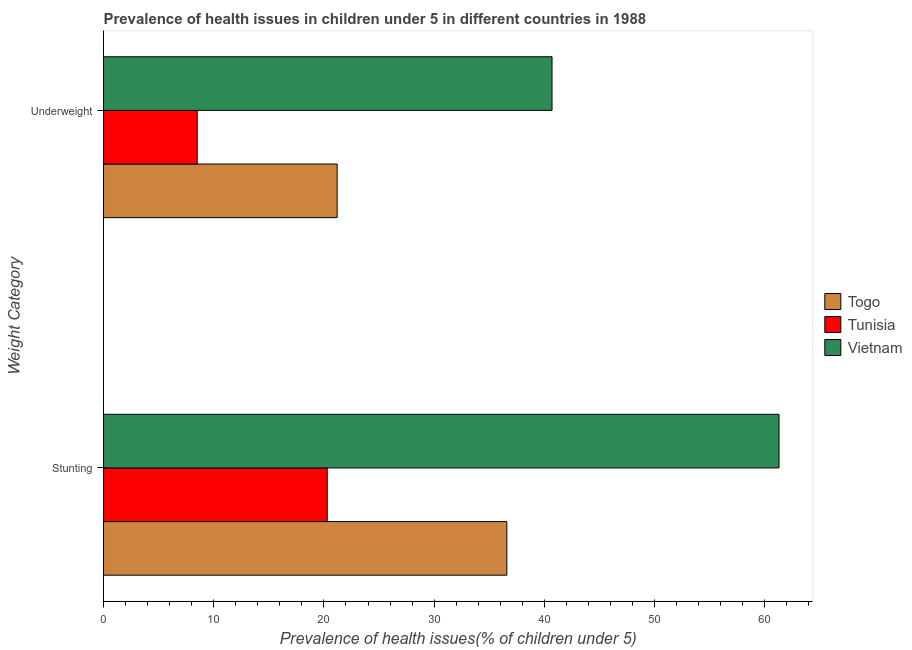Are the number of bars on each tick of the Y-axis equal?
Keep it short and to the point. Yes. How many bars are there on the 2nd tick from the top?
Your answer should be compact. 3. How many bars are there on the 2nd tick from the bottom?
Keep it short and to the point. 3. What is the label of the 2nd group of bars from the top?
Your answer should be compact. Stunting. What is the percentage of stunted children in Vietnam?
Your answer should be compact. 61.3. Across all countries, what is the maximum percentage of stunted children?
Offer a very short reply. 61.3. In which country was the percentage of stunted children maximum?
Your response must be concise. Vietnam. In which country was the percentage of underweight children minimum?
Give a very brief answer. Tunisia. What is the total percentage of stunted children in the graph?
Give a very brief answer. 118.2. What is the difference between the percentage of underweight children in Tunisia and that in Togo?
Provide a short and direct response. -12.7. What is the difference between the percentage of stunted children in Vietnam and the percentage of underweight children in Togo?
Keep it short and to the point. 40.1. What is the average percentage of stunted children per country?
Your answer should be very brief. 39.4. What is the difference between the percentage of stunted children and percentage of underweight children in Tunisia?
Offer a terse response. 11.8. In how many countries, is the percentage of underweight children greater than 50 %?
Offer a very short reply. 0. What is the ratio of the percentage of underweight children in Vietnam to that in Tunisia?
Ensure brevity in your answer.  4.79. Is the percentage of underweight children in Togo less than that in Tunisia?
Offer a very short reply. No. In how many countries, is the percentage of stunted children greater than the average percentage of stunted children taken over all countries?
Offer a very short reply. 1. What does the 2nd bar from the top in Stunting represents?
Your answer should be very brief. Tunisia. What does the 2nd bar from the bottom in Stunting represents?
Offer a terse response. Tunisia. What is the difference between two consecutive major ticks on the X-axis?
Keep it short and to the point. 10. Does the graph contain any zero values?
Your answer should be very brief. No. Does the graph contain grids?
Provide a short and direct response. No. Where does the legend appear in the graph?
Your response must be concise. Center right. How many legend labels are there?
Make the answer very short. 3. How are the legend labels stacked?
Your answer should be compact. Vertical. What is the title of the graph?
Keep it short and to the point. Prevalence of health issues in children under 5 in different countries in 1988. Does "Botswana" appear as one of the legend labels in the graph?
Your answer should be compact. No. What is the label or title of the X-axis?
Keep it short and to the point. Prevalence of health issues(% of children under 5). What is the label or title of the Y-axis?
Provide a succinct answer. Weight Category. What is the Prevalence of health issues(% of children under 5) in Togo in Stunting?
Ensure brevity in your answer.  36.6. What is the Prevalence of health issues(% of children under 5) of Tunisia in Stunting?
Your answer should be very brief. 20.3. What is the Prevalence of health issues(% of children under 5) of Vietnam in Stunting?
Make the answer very short. 61.3. What is the Prevalence of health issues(% of children under 5) in Togo in Underweight?
Keep it short and to the point. 21.2. What is the Prevalence of health issues(% of children under 5) of Tunisia in Underweight?
Ensure brevity in your answer.  8.5. What is the Prevalence of health issues(% of children under 5) of Vietnam in Underweight?
Provide a short and direct response. 40.7. Across all Weight Category, what is the maximum Prevalence of health issues(% of children under 5) in Togo?
Offer a very short reply. 36.6. Across all Weight Category, what is the maximum Prevalence of health issues(% of children under 5) of Tunisia?
Ensure brevity in your answer.  20.3. Across all Weight Category, what is the maximum Prevalence of health issues(% of children under 5) of Vietnam?
Offer a very short reply. 61.3. Across all Weight Category, what is the minimum Prevalence of health issues(% of children under 5) in Togo?
Give a very brief answer. 21.2. Across all Weight Category, what is the minimum Prevalence of health issues(% of children under 5) in Vietnam?
Make the answer very short. 40.7. What is the total Prevalence of health issues(% of children under 5) of Togo in the graph?
Your answer should be compact. 57.8. What is the total Prevalence of health issues(% of children under 5) of Tunisia in the graph?
Ensure brevity in your answer.  28.8. What is the total Prevalence of health issues(% of children under 5) of Vietnam in the graph?
Offer a terse response. 102. What is the difference between the Prevalence of health issues(% of children under 5) of Togo in Stunting and that in Underweight?
Ensure brevity in your answer.  15.4. What is the difference between the Prevalence of health issues(% of children under 5) in Vietnam in Stunting and that in Underweight?
Give a very brief answer. 20.6. What is the difference between the Prevalence of health issues(% of children under 5) of Togo in Stunting and the Prevalence of health issues(% of children under 5) of Tunisia in Underweight?
Offer a terse response. 28.1. What is the difference between the Prevalence of health issues(% of children under 5) of Tunisia in Stunting and the Prevalence of health issues(% of children under 5) of Vietnam in Underweight?
Keep it short and to the point. -20.4. What is the average Prevalence of health issues(% of children under 5) in Togo per Weight Category?
Provide a short and direct response. 28.9. What is the average Prevalence of health issues(% of children under 5) of Vietnam per Weight Category?
Ensure brevity in your answer.  51. What is the difference between the Prevalence of health issues(% of children under 5) in Togo and Prevalence of health issues(% of children under 5) in Tunisia in Stunting?
Provide a succinct answer. 16.3. What is the difference between the Prevalence of health issues(% of children under 5) of Togo and Prevalence of health issues(% of children under 5) of Vietnam in Stunting?
Provide a succinct answer. -24.7. What is the difference between the Prevalence of health issues(% of children under 5) of Tunisia and Prevalence of health issues(% of children under 5) of Vietnam in Stunting?
Offer a terse response. -41. What is the difference between the Prevalence of health issues(% of children under 5) in Togo and Prevalence of health issues(% of children under 5) in Vietnam in Underweight?
Offer a very short reply. -19.5. What is the difference between the Prevalence of health issues(% of children under 5) of Tunisia and Prevalence of health issues(% of children under 5) of Vietnam in Underweight?
Your answer should be very brief. -32.2. What is the ratio of the Prevalence of health issues(% of children under 5) of Togo in Stunting to that in Underweight?
Ensure brevity in your answer.  1.73. What is the ratio of the Prevalence of health issues(% of children under 5) of Tunisia in Stunting to that in Underweight?
Provide a succinct answer. 2.39. What is the ratio of the Prevalence of health issues(% of children under 5) in Vietnam in Stunting to that in Underweight?
Offer a terse response. 1.51. What is the difference between the highest and the second highest Prevalence of health issues(% of children under 5) in Togo?
Your response must be concise. 15.4. What is the difference between the highest and the second highest Prevalence of health issues(% of children under 5) of Vietnam?
Provide a succinct answer. 20.6. What is the difference between the highest and the lowest Prevalence of health issues(% of children under 5) of Togo?
Your answer should be very brief. 15.4. What is the difference between the highest and the lowest Prevalence of health issues(% of children under 5) of Vietnam?
Offer a very short reply. 20.6. 